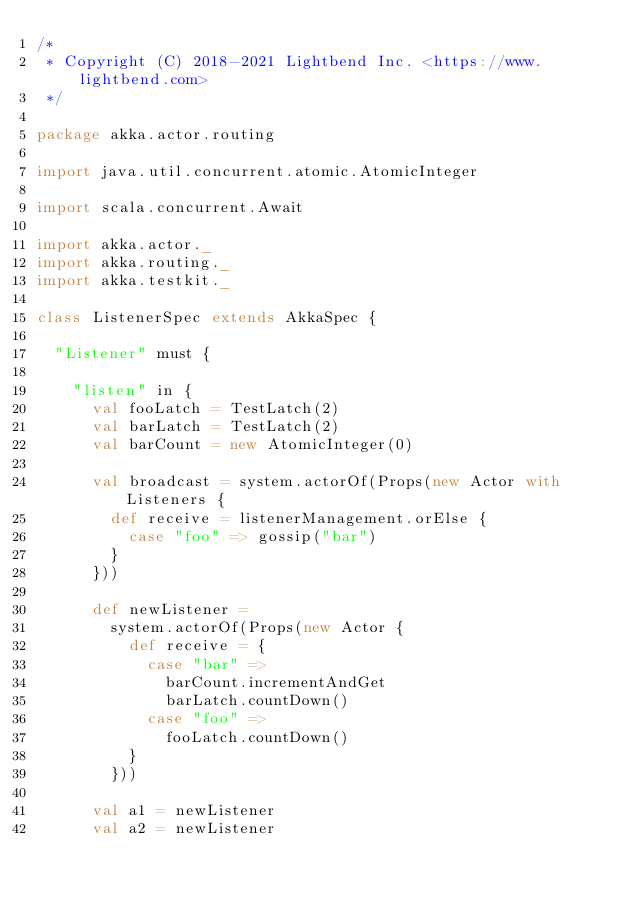<code> <loc_0><loc_0><loc_500><loc_500><_Scala_>/*
 * Copyright (C) 2018-2021 Lightbend Inc. <https://www.lightbend.com>
 */

package akka.actor.routing

import java.util.concurrent.atomic.AtomicInteger

import scala.concurrent.Await

import akka.actor._
import akka.routing._
import akka.testkit._

class ListenerSpec extends AkkaSpec {

  "Listener" must {

    "listen" in {
      val fooLatch = TestLatch(2)
      val barLatch = TestLatch(2)
      val barCount = new AtomicInteger(0)

      val broadcast = system.actorOf(Props(new Actor with Listeners {
        def receive = listenerManagement.orElse {
          case "foo" => gossip("bar")
        }
      }))

      def newListener =
        system.actorOf(Props(new Actor {
          def receive = {
            case "bar" =>
              barCount.incrementAndGet
              barLatch.countDown()
            case "foo" =>
              fooLatch.countDown()
          }
        }))

      val a1 = newListener
      val a2 = newListener</code> 